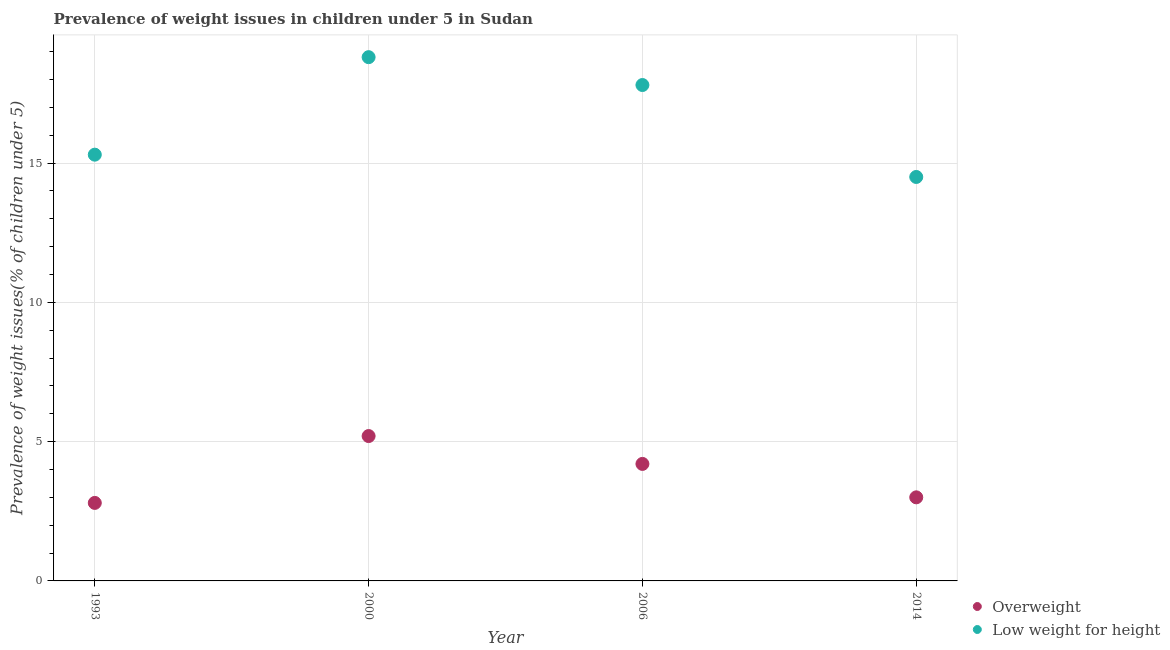Is the number of dotlines equal to the number of legend labels?
Your response must be concise. Yes. What is the percentage of underweight children in 2000?
Make the answer very short. 18.8. Across all years, what is the maximum percentage of underweight children?
Offer a terse response. 18.8. In which year was the percentage of overweight children maximum?
Keep it short and to the point. 2000. What is the total percentage of underweight children in the graph?
Make the answer very short. 66.4. What is the difference between the percentage of underweight children in 2006 and the percentage of overweight children in 2000?
Your answer should be compact. 12.6. What is the average percentage of underweight children per year?
Your response must be concise. 16.6. In how many years, is the percentage of underweight children greater than 6 %?
Give a very brief answer. 4. What is the ratio of the percentage of overweight children in 2006 to that in 2014?
Ensure brevity in your answer.  1.4. Is the percentage of underweight children in 1993 less than that in 2006?
Provide a succinct answer. Yes. What is the difference between the highest and the lowest percentage of overweight children?
Your answer should be very brief. 2.4. Is the sum of the percentage of underweight children in 2006 and 2014 greater than the maximum percentage of overweight children across all years?
Provide a short and direct response. Yes. Does the percentage of underweight children monotonically increase over the years?
Your response must be concise. No. Is the percentage of overweight children strictly less than the percentage of underweight children over the years?
Your response must be concise. Yes. How many years are there in the graph?
Provide a succinct answer. 4. What is the difference between two consecutive major ticks on the Y-axis?
Offer a terse response. 5. Are the values on the major ticks of Y-axis written in scientific E-notation?
Your answer should be very brief. No. Does the graph contain any zero values?
Provide a succinct answer. No. Does the graph contain grids?
Offer a terse response. Yes. How are the legend labels stacked?
Offer a very short reply. Vertical. What is the title of the graph?
Give a very brief answer. Prevalence of weight issues in children under 5 in Sudan. Does "Goods and services" appear as one of the legend labels in the graph?
Keep it short and to the point. No. What is the label or title of the Y-axis?
Ensure brevity in your answer.  Prevalence of weight issues(% of children under 5). What is the Prevalence of weight issues(% of children under 5) in Overweight in 1993?
Your response must be concise. 2.8. What is the Prevalence of weight issues(% of children under 5) in Low weight for height in 1993?
Your answer should be very brief. 15.3. What is the Prevalence of weight issues(% of children under 5) in Overweight in 2000?
Make the answer very short. 5.2. What is the Prevalence of weight issues(% of children under 5) of Low weight for height in 2000?
Make the answer very short. 18.8. What is the Prevalence of weight issues(% of children under 5) in Overweight in 2006?
Your response must be concise. 4.2. What is the Prevalence of weight issues(% of children under 5) in Low weight for height in 2006?
Ensure brevity in your answer.  17.8. What is the Prevalence of weight issues(% of children under 5) of Overweight in 2014?
Offer a terse response. 3. Across all years, what is the maximum Prevalence of weight issues(% of children under 5) of Overweight?
Your response must be concise. 5.2. Across all years, what is the maximum Prevalence of weight issues(% of children under 5) in Low weight for height?
Your answer should be compact. 18.8. Across all years, what is the minimum Prevalence of weight issues(% of children under 5) of Overweight?
Provide a succinct answer. 2.8. What is the total Prevalence of weight issues(% of children under 5) in Low weight for height in the graph?
Keep it short and to the point. 66.4. What is the difference between the Prevalence of weight issues(% of children under 5) in Overweight in 1993 and that in 2006?
Make the answer very short. -1.4. What is the difference between the Prevalence of weight issues(% of children under 5) of Overweight in 1993 and that in 2014?
Offer a terse response. -0.2. What is the difference between the Prevalence of weight issues(% of children under 5) of Low weight for height in 2006 and that in 2014?
Offer a terse response. 3.3. What is the difference between the Prevalence of weight issues(% of children under 5) of Overweight in 1993 and the Prevalence of weight issues(% of children under 5) of Low weight for height in 2000?
Your response must be concise. -16. What is the difference between the Prevalence of weight issues(% of children under 5) of Overweight in 2000 and the Prevalence of weight issues(% of children under 5) of Low weight for height in 2006?
Offer a terse response. -12.6. What is the average Prevalence of weight issues(% of children under 5) in Overweight per year?
Give a very brief answer. 3.8. In the year 2006, what is the difference between the Prevalence of weight issues(% of children under 5) in Overweight and Prevalence of weight issues(% of children under 5) in Low weight for height?
Ensure brevity in your answer.  -13.6. What is the ratio of the Prevalence of weight issues(% of children under 5) in Overweight in 1993 to that in 2000?
Ensure brevity in your answer.  0.54. What is the ratio of the Prevalence of weight issues(% of children under 5) in Low weight for height in 1993 to that in 2000?
Make the answer very short. 0.81. What is the ratio of the Prevalence of weight issues(% of children under 5) in Low weight for height in 1993 to that in 2006?
Your answer should be compact. 0.86. What is the ratio of the Prevalence of weight issues(% of children under 5) in Overweight in 1993 to that in 2014?
Your answer should be compact. 0.93. What is the ratio of the Prevalence of weight issues(% of children under 5) in Low weight for height in 1993 to that in 2014?
Give a very brief answer. 1.06. What is the ratio of the Prevalence of weight issues(% of children under 5) in Overweight in 2000 to that in 2006?
Ensure brevity in your answer.  1.24. What is the ratio of the Prevalence of weight issues(% of children under 5) in Low weight for height in 2000 to that in 2006?
Your answer should be very brief. 1.06. What is the ratio of the Prevalence of weight issues(% of children under 5) in Overweight in 2000 to that in 2014?
Offer a terse response. 1.73. What is the ratio of the Prevalence of weight issues(% of children under 5) of Low weight for height in 2000 to that in 2014?
Ensure brevity in your answer.  1.3. What is the ratio of the Prevalence of weight issues(% of children under 5) in Overweight in 2006 to that in 2014?
Offer a very short reply. 1.4. What is the ratio of the Prevalence of weight issues(% of children under 5) in Low weight for height in 2006 to that in 2014?
Keep it short and to the point. 1.23. What is the difference between the highest and the second highest Prevalence of weight issues(% of children under 5) in Overweight?
Offer a terse response. 1. What is the difference between the highest and the lowest Prevalence of weight issues(% of children under 5) of Low weight for height?
Provide a succinct answer. 4.3. 